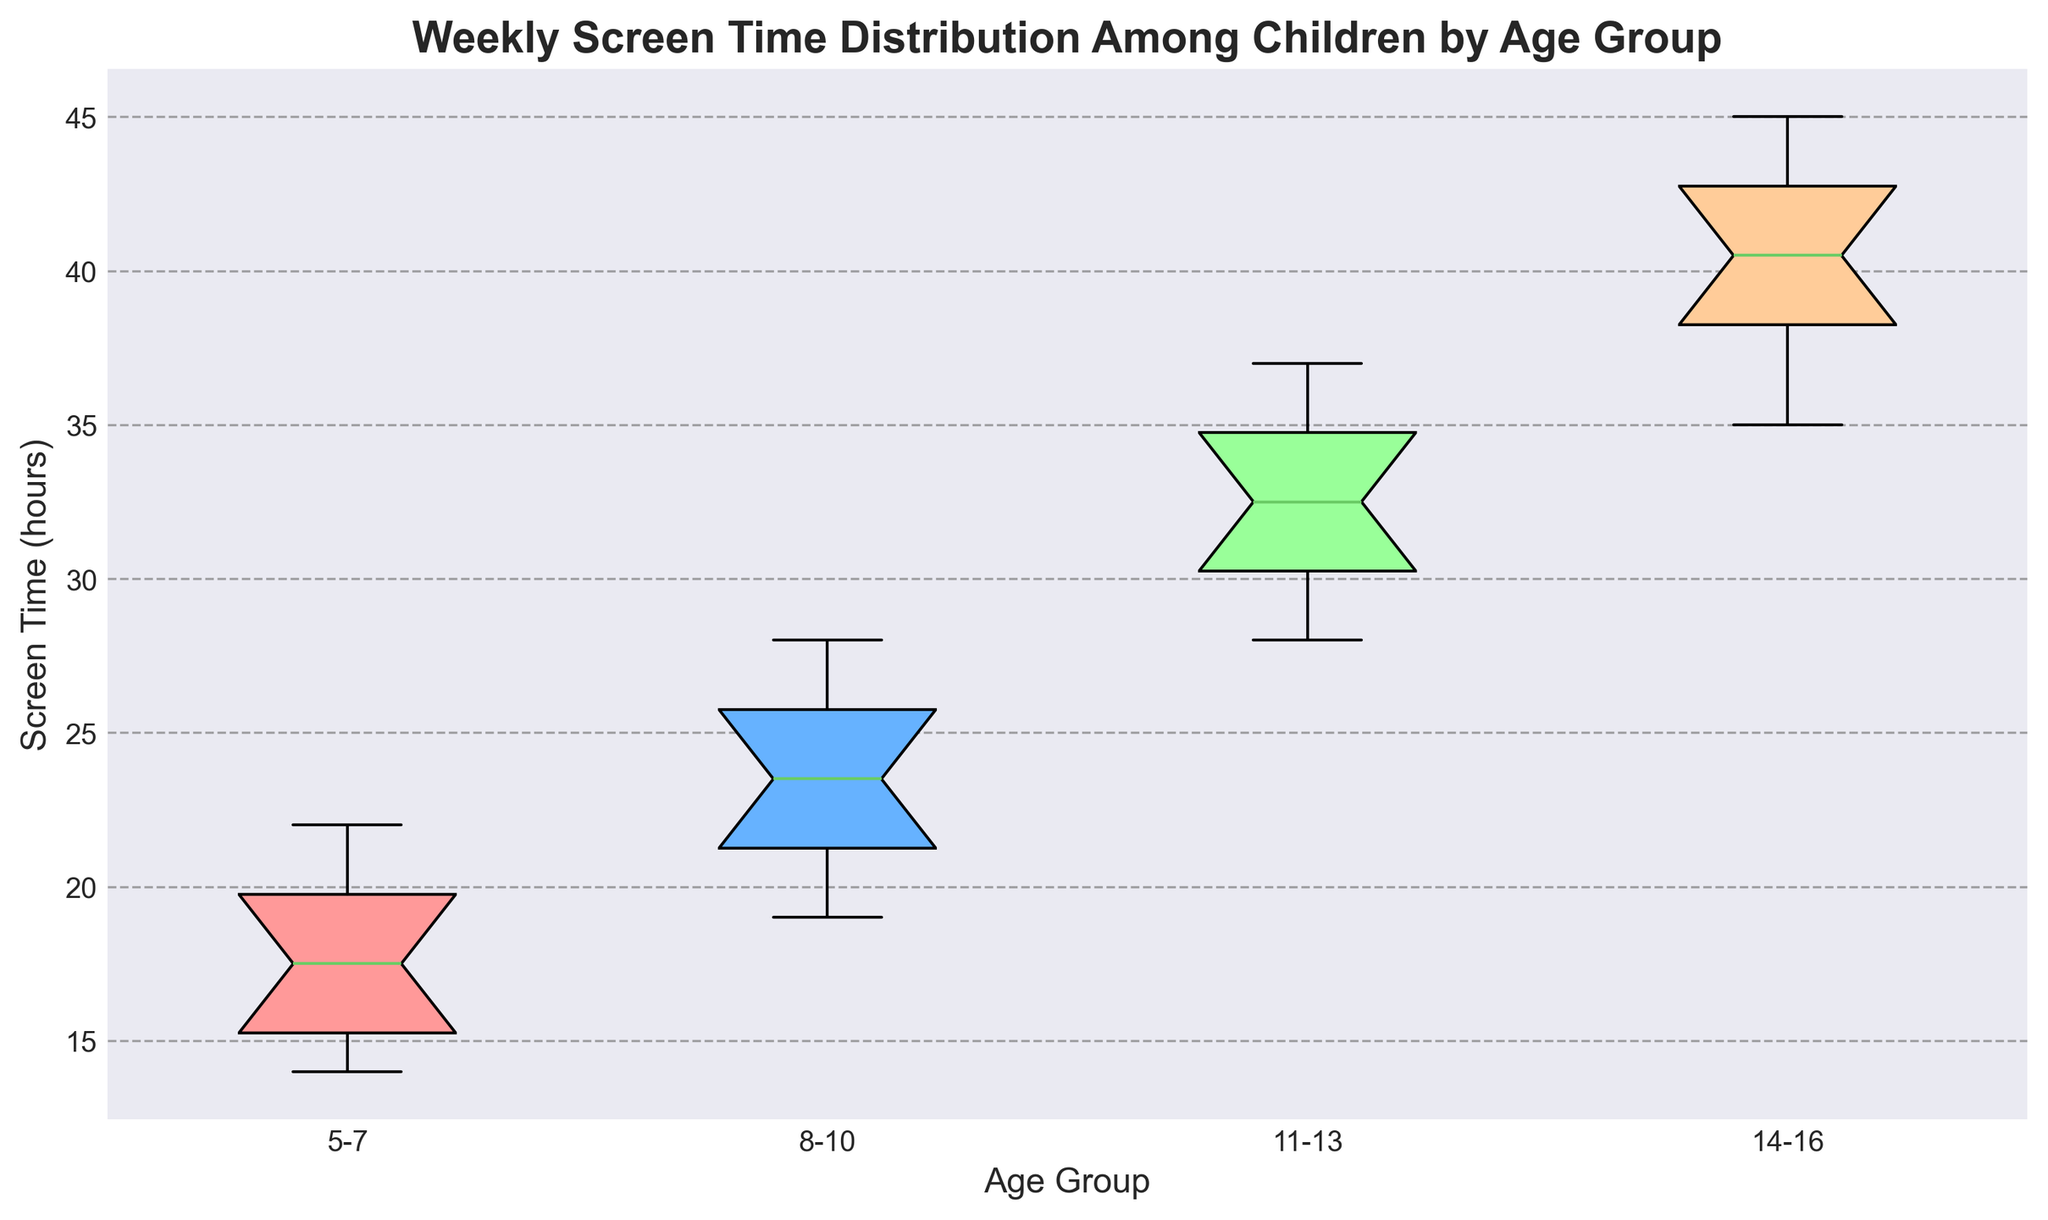What is the median weekly screen time for the age group 11-13? To determine the median weekly screen time, look at the middle value of the age group 11-13 within the box plot. Since the median divides the box into two equal halves, it can be directly observed from the middle line inside the box.
Answer: 32 hours Which age group has the highest median screen time? Compare the median lines (the middle lines within each box) of all age groups. The age group with the highest median line represents the highest median screen time.
Answer: 14-16 Which age group shows the widest range of screen time values? The range of screen time values is represented by the distance between the bottom and top whiskers in each box plot. Identify the age group whose whiskers are the most spread apart.
Answer: 14-16 By how many hours does the median screen time for the age group 8-10 exceed that of the age group 5-7? Observe the median lines within the box plots for both age groups. Subtract the median screen time of 5-7 from the median screen time of 8-10. The median for 8-10 is 23.5 hours and for 5-7 is 17 hours.
Answer: 6.5 hours What is the interquartile range (IQR) for the age group 5-7? The IQR is the range between the first (Q1) and third quartiles (Q3). In the box plot, Q1 is the lower boundary of the box, and Q3 is the upper boundary of the box. Calculate the difference between Q3 and Q1 for the age group 5-7. Q1 is 15 and Q3 is 20.
Answer: 5 hours Which age group has the smallest variability in weekly screen time? Variability is indicated by the spread of the box and whiskers. The age group with the narrowest total range (whiskers) and shortest box length has the smallest variability.
Answer: 5-7 Which age group has the most consistent screen time values, as indicated by the shortest box length? Consistent screen time values are shown by a shorter length of the box, indicating the interquartile range is narrow. Locate the age group with the shortest box in the plot.
Answer: 5-7 Are there any outliers in the screen time for any age group? If so, which group(s)? Outliers in a box plot are represented by points outside the whiskers. Identify if there are any individual points outside of the whiskers for any age groups.
Answer: No outliers What can we infer about the general trend in screen time as age increases? Analyze the general position of the medians and the spread of the boxes and whiskers across the age groups to understand the trend. Notice if the boxes and medians shift higher as age increases.
Answer: Screen time increases with age 